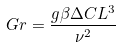Convert formula to latex. <formula><loc_0><loc_0><loc_500><loc_500>G r = \frac { g \beta \Delta C L ^ { 3 } } { \nu ^ { 2 } }</formula> 